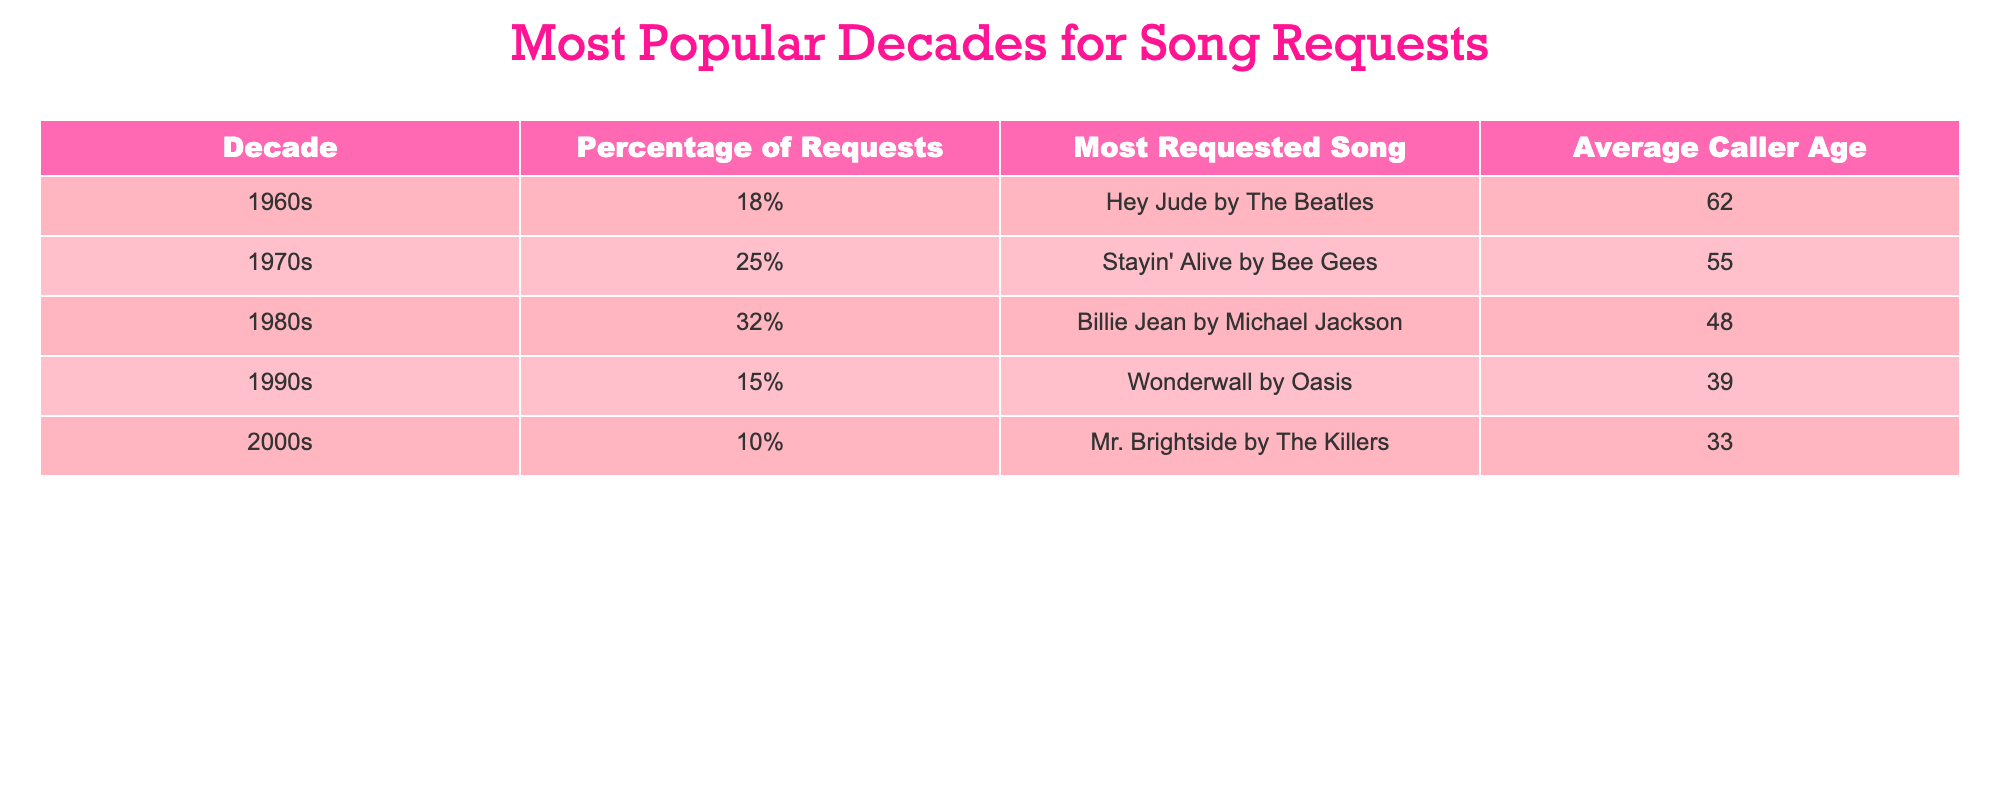What decade received the highest percentage of song requests? The table shows that the 1980s had the highest percentage of song requests at 32%.
Answer: 1980s What is the most requested song from the 1970s? According to the table, the most requested song from the 1970s is "Stayin' Alive" by the Bee Gees.
Answer: "Stayin' Alive" by the Bee Gees Which decade had the lowest percentage of requests? The table indicates that the 2000s had the lowest percentage of song requests, which is 10%.
Answer: 2000s What is the average caller age for the 1960s? The table states that the average caller age for the 1960s is 62 years old.
Answer: 62 What percentage of requests were made for the 1990s songs compared to the 1980s? The percentage of requests for 1990s songs is 15%, while for the 1980s, it is 32%. The difference is 32% - 15% = 17%.
Answer: 17% Which decade had a more significant percentage of requests: the 1960s or the 1990s? The requests for the 1960s were at 18%, and for the 1990s at 15%. Since 18% is greater than 15%, the 1960s had a more significant percentage of requests.
Answer: 1960s What is the average percentage of requests across all decades? To find the average percentage of requests, we add up all the percentages: 18% + 25% + 32% + 15% + 10% = 100%. Then divide by the number of decades (5): 100% / 5 = 20%.
Answer: 20% Is "Wonderwall" by Oasis the most requested song overall? The table shows the most requested song for each decade; "Billie Jean" by Michael Jackson from the 1980s is the most requested overall, not "Wonderwall."
Answer: No Which decade has the youngest average caller age based on the table? The average caller ages are 62 for the 1960s, 55 for the 1970s, 48 for the 1980s, 39 for the 1990s, and 33 for the 2000s. The youngest average caller age is for the 2000s at 33 years old.
Answer: 2000s What is the average age of callers from the 1970s and 1980s combined? The average age for the 1970s is 55 and for the 1980s is 48. To find the average, we add them (55 + 48 = 103) and divide by 2, which gives us an average of 51.5.
Answer: 51.5 